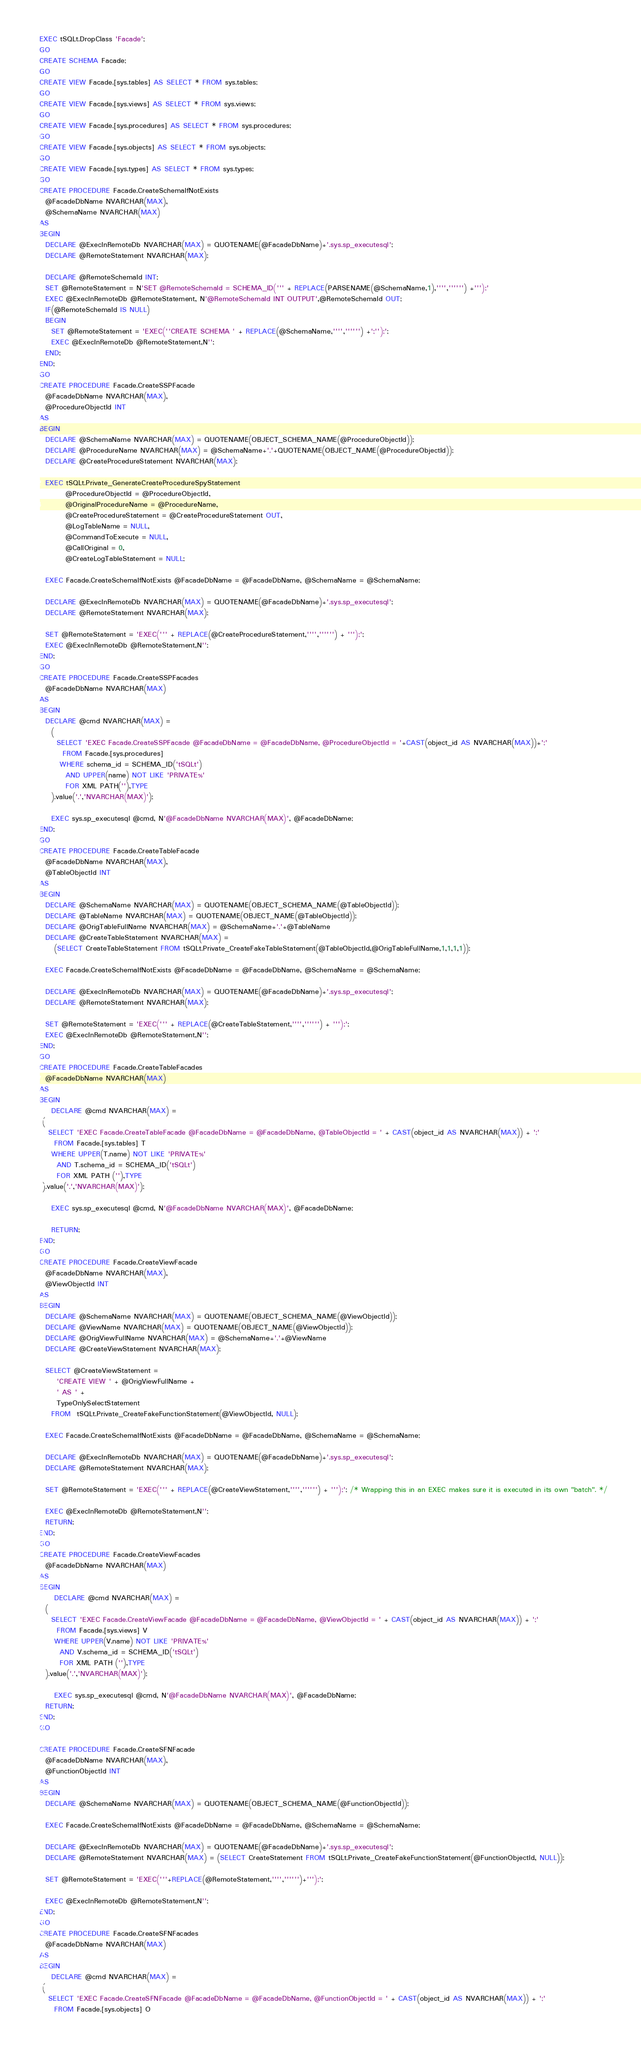Convert code to text. <code><loc_0><loc_0><loc_500><loc_500><_SQL_>EXEC tSQLt.DropClass 'Facade';
GO
CREATE SCHEMA Facade;
GO
CREATE VIEW Facade.[sys.tables] AS SELECT * FROM sys.tables;
GO
CREATE VIEW Facade.[sys.views] AS SELECT * FROM sys.views;
GO
CREATE VIEW Facade.[sys.procedures] AS SELECT * FROM sys.procedures;
GO
CREATE VIEW Facade.[sys.objects] AS SELECT * FROM sys.objects;
GO
CREATE VIEW Facade.[sys.types] AS SELECT * FROM sys.types;
GO
CREATE PROCEDURE Facade.CreateSchemaIfNotExists
  @FacadeDbName NVARCHAR(MAX), 
  @SchemaName NVARCHAR(MAX) 
AS
BEGIN
  DECLARE @ExecInRemoteDb NVARCHAR(MAX) = QUOTENAME(@FacadeDbName)+'.sys.sp_executesql';
  DECLARE @RemoteStatement NVARCHAR(MAX);

  DECLARE @RemoteSchemaId INT;
  SET @RemoteStatement = N'SET @RemoteSchemaId = SCHEMA_ID(''' + REPLACE(PARSENAME(@SchemaName,1),'''','''''') +''');'
  EXEC @ExecInRemoteDb @RemoteStatement, N'@RemoteSchemaId INT OUTPUT',@RemoteSchemaId OUT; 
  IF(@RemoteSchemaId IS NULL)
  BEGIN
    SET @RemoteStatement = 'EXEC(''CREATE SCHEMA ' + REPLACE(@SchemaName,'''','''''') +';'');';
    EXEC @ExecInRemoteDb @RemoteStatement,N'';
  END;   
END;
GO
CREATE PROCEDURE Facade.CreateSSPFacade
  @FacadeDbName NVARCHAR(MAX), 
  @ProcedureObjectId INT
AS
BEGIN
  DECLARE @SchemaName NVARCHAR(MAX) = QUOTENAME(OBJECT_SCHEMA_NAME(@ProcedureObjectId));
  DECLARE @ProcedureName NVARCHAR(MAX) = @SchemaName+'.'+QUOTENAME(OBJECT_NAME(@ProcedureObjectId));
  DECLARE @CreateProcedureStatement NVARCHAR(MAX);

  EXEC tSQLt.Private_GenerateCreateProcedureSpyStatement 
         @ProcedureObjectId = @ProcedureObjectId,
         @OriginalProcedureName = @ProcedureName,
         @CreateProcedureStatement = @CreateProcedureStatement OUT,
         @LogTableName = NULL,
         @CommandToExecute = NULL,
         @CallOriginal = 0,
         @CreateLogTableStatement = NULL;
  
  EXEC Facade.CreateSchemaIfNotExists @FacadeDbName = @FacadeDbName, @SchemaName = @SchemaName;

  DECLARE @ExecInRemoteDb NVARCHAR(MAX) = QUOTENAME(@FacadeDbName)+'.sys.sp_executesql';
  DECLARE @RemoteStatement NVARCHAR(MAX);

  SET @RemoteStatement = 'EXEC(''' + REPLACE(@CreateProcedureStatement,'''','''''') + ''');';
  EXEC @ExecInRemoteDb @RemoteStatement,N'';
END;
GO
CREATE PROCEDURE Facade.CreateSSPFacades
  @FacadeDbName NVARCHAR(MAX)
AS
BEGIN
  DECLARE @cmd NVARCHAR(MAX) = 
    (
      SELECT 'EXEC Facade.CreateSSPFacade @FacadeDbName = @FacadeDbName, @ProcedureObjectId = '+CAST(object_id AS NVARCHAR(MAX))+';'
        FROM Facade.[sys.procedures]
       WHERE schema_id = SCHEMA_ID('tSQLt')
         AND UPPER(name) NOT LIKE 'PRIVATE%'
         FOR XML PATH(''),TYPE
    ).value('.','NVARCHAR(MAX)');

	EXEC sys.sp_executesql @cmd, N'@FacadeDbName NVARCHAR(MAX)', @FacadeDbName;
END;
GO
CREATE PROCEDURE Facade.CreateTableFacade
  @FacadeDbName NVARCHAR(MAX), 
  @TableObjectId INT
AS
BEGIN
  DECLARE @SchemaName NVARCHAR(MAX) = QUOTENAME(OBJECT_SCHEMA_NAME(@TableObjectId));
  DECLARE @TableName NVARCHAR(MAX) = QUOTENAME(OBJECT_NAME(@TableObjectId));
  DECLARE @OrigTableFullName NVARCHAR(MAX) = @SchemaName+'.'+@TableName
  DECLARE @CreateTableStatement NVARCHAR(MAX) = 
     (SELECT CreateTableStatement FROM tSQLt.Private_CreateFakeTableStatement(@TableObjectId,@OrigTableFullName,1,1,1,1));
  
  EXEC Facade.CreateSchemaIfNotExists @FacadeDbName = @FacadeDbName, @SchemaName = @SchemaName;

  DECLARE @ExecInRemoteDb NVARCHAR(MAX) = QUOTENAME(@FacadeDbName)+'.sys.sp_executesql';
  DECLARE @RemoteStatement NVARCHAR(MAX);

  SET @RemoteStatement = 'EXEC(''' + REPLACE(@CreateTableStatement,'''','''''') + ''');';
  EXEC @ExecInRemoteDb @RemoteStatement,N'';
END;
GO
CREATE PROCEDURE Facade.CreateTableFacades
  @FacadeDbName NVARCHAR(MAX)
AS
BEGIN
	DECLARE @cmd NVARCHAR(MAX) = 
 (
   SELECT 'EXEC Facade.CreateTableFacade @FacadeDbName = @FacadeDbName, @TableObjectId = ' + CAST(object_id AS NVARCHAR(MAX)) + ';'
     FROM Facade.[sys.tables] T
    WHERE UPPER(T.name) NOT LIKE 'PRIVATE%'
      AND T.schema_id = SCHEMA_ID('tSQLt')
      FOR XML PATH (''),TYPE
 ).value('.','NVARCHAR(MAX)');
    
	EXEC sys.sp_executesql @cmd, N'@FacadeDbName NVARCHAR(MAX)', @FacadeDbName;

	RETURN;
END;
GO
CREATE PROCEDURE Facade.CreateViewFacade
  @FacadeDbName NVARCHAR(MAX),
  @ViewObjectId INT
AS
BEGIN
  DECLARE @SchemaName NVARCHAR(MAX) = QUOTENAME(OBJECT_SCHEMA_NAME(@ViewObjectId));
  DECLARE @ViewName NVARCHAR(MAX) = QUOTENAME(OBJECT_NAME(@ViewObjectId));
  DECLARE @OrigViewFullName NVARCHAR(MAX) = @SchemaName+'.'+@ViewName
  DECLARE @CreateViewStatement NVARCHAR(MAX);

  SELECT @CreateViewStatement = 
      'CREATE VIEW ' + @OrigViewFullName + 
      ' AS ' + 
      TypeOnlySelectStatement 
    FROM  tSQLt.Private_CreateFakeFunctionStatement(@ViewObjectId, NULL);

  EXEC Facade.CreateSchemaIfNotExists @FacadeDbName = @FacadeDbName, @SchemaName = @SchemaName;
    
  DECLARE @ExecInRemoteDb NVARCHAR(MAX) = QUOTENAME(@FacadeDbName)+'.sys.sp_executesql';
  DECLARE @RemoteStatement NVARCHAR(MAX);

  SET @RemoteStatement = 'EXEC(''' + REPLACE(@CreateViewStatement,'''','''''') + ''');'; /* Wrapping this in an EXEC makes sure it is executed in its own "batch". */
  
  EXEC @ExecInRemoteDb @RemoteStatement,N'';
  RETURN;
END;
GO
CREATE PROCEDURE Facade.CreateViewFacades
  @FacadeDbName NVARCHAR(MAX)
AS
BEGIN
	 DECLARE @cmd NVARCHAR(MAX) = 
  (
    SELECT 'EXEC Facade.CreateViewFacade @FacadeDbName = @FacadeDbName, @ViewObjectId = ' + CAST(object_id AS NVARCHAR(MAX)) + ';'
      FROM Facade.[sys.views] V
     WHERE UPPER(V.name) NOT LIKE 'PRIVATE%'
       AND V.schema_id = SCHEMA_ID('tSQLt')
       FOR XML PATH (''),TYPE
  ).value('.','NVARCHAR(MAX)');
    
	 EXEC sys.sp_executesql @cmd, N'@FacadeDbName NVARCHAR(MAX)', @FacadeDbName;
  RETURN;
END;
GO

CREATE PROCEDURE Facade.CreateSFNFacade
  @FacadeDbName NVARCHAR(MAX), 
  @FunctionObjectId INT
AS
BEGIN
  DECLARE @SchemaName NVARCHAR(MAX) = QUOTENAME(OBJECT_SCHEMA_NAME(@FunctionObjectId));

  EXEC Facade.CreateSchemaIfNotExists @FacadeDbName = @FacadeDbName, @SchemaName = @SchemaName;

  DECLARE @ExecInRemoteDb NVARCHAR(MAX) = QUOTENAME(@FacadeDbName)+'.sys.sp_executesql';
  DECLARE @RemoteStatement NVARCHAR(MAX) = (SELECT CreateStatement FROM tSQLt.Private_CreateFakeFunctionStatement(@FunctionObjectId, NULL));

  SET @RemoteStatement = 'EXEC('''+REPLACE(@RemoteStatement,'''','''''')+''');';

  EXEC @ExecInRemoteDb @RemoteStatement,N'';
END;
GO
CREATE PROCEDURE Facade.CreateSFNFacades
  @FacadeDbName NVARCHAR(MAX)
AS
BEGIN
	DECLARE @cmd NVARCHAR(MAX) = 
 (
   SELECT 'EXEC Facade.CreateSFNFacade @FacadeDbName = @FacadeDbName, @FunctionObjectId = ' + CAST(object_id AS NVARCHAR(MAX)) + ';'
     FROM Facade.[sys.objects] O</code> 